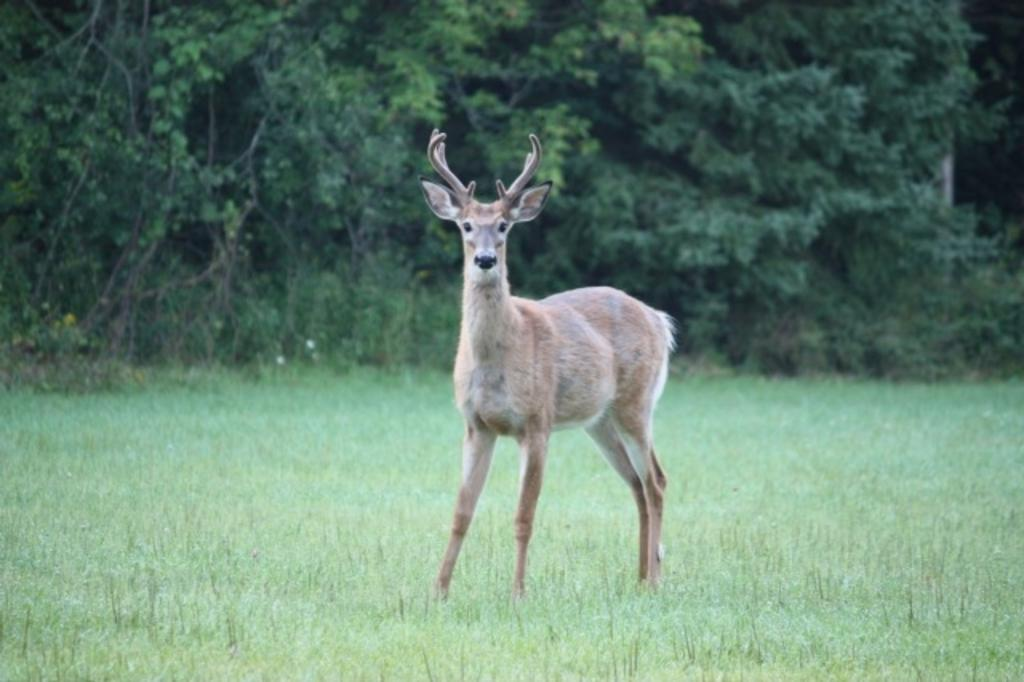What animal is the main subject of the image? There is a deer in the image. Where is the deer located in the image? The deer is standing in the middle of the image. What type of vegetation is at the bottom of the image? There is grass at the bottom of the image. What can be seen in the background of the image? There are trees in the background of the image. Is the deer stuck in quicksand in the image? No, there is no quicksand present in the image, and the deer is standing on grass. Can you provide an example of a watch that the deer might be wearing in the image? Deer do not wear watches, and there is no watch present in the image. 